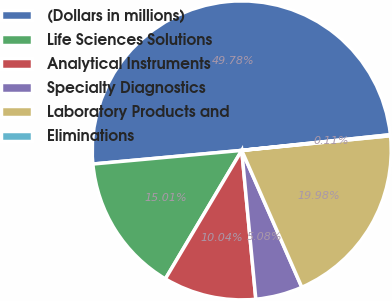Convert chart to OTSL. <chart><loc_0><loc_0><loc_500><loc_500><pie_chart><fcel>(Dollars in millions)<fcel>Life Sciences Solutions<fcel>Analytical Instruments<fcel>Specialty Diagnostics<fcel>Laboratory Products and<fcel>Eliminations<nl><fcel>49.78%<fcel>15.01%<fcel>10.04%<fcel>5.08%<fcel>19.98%<fcel>0.11%<nl></chart> 